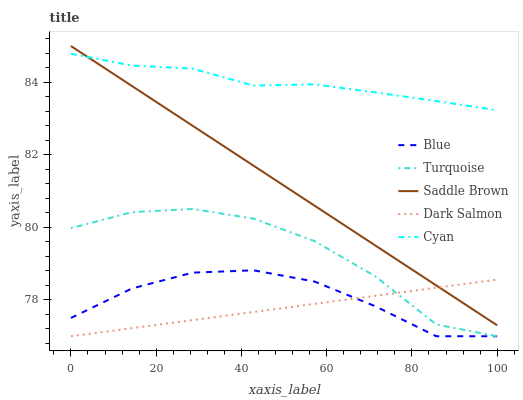Does Dark Salmon have the minimum area under the curve?
Answer yes or no. Yes. Does Cyan have the maximum area under the curve?
Answer yes or no. Yes. Does Turquoise have the minimum area under the curve?
Answer yes or no. No. Does Turquoise have the maximum area under the curve?
Answer yes or no. No. Is Saddle Brown the smoothest?
Answer yes or no. Yes. Is Turquoise the roughest?
Answer yes or no. Yes. Is Cyan the smoothest?
Answer yes or no. No. Is Cyan the roughest?
Answer yes or no. No. Does Blue have the lowest value?
Answer yes or no. Yes. Does Cyan have the lowest value?
Answer yes or no. No. Does Saddle Brown have the highest value?
Answer yes or no. Yes. Does Cyan have the highest value?
Answer yes or no. No. Is Dark Salmon less than Cyan?
Answer yes or no. Yes. Is Saddle Brown greater than Blue?
Answer yes or no. Yes. Does Saddle Brown intersect Cyan?
Answer yes or no. Yes. Is Saddle Brown less than Cyan?
Answer yes or no. No. Is Saddle Brown greater than Cyan?
Answer yes or no. No. Does Dark Salmon intersect Cyan?
Answer yes or no. No. 